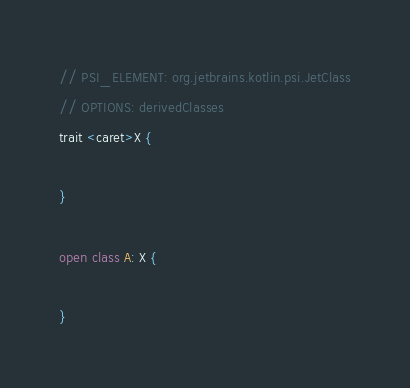Convert code to text. <code><loc_0><loc_0><loc_500><loc_500><_Kotlin_>// PSI_ELEMENT: org.jetbrains.kotlin.psi.JetClass
// OPTIONS: derivedClasses
trait <caret>X {

}

open class A: X {

}
</code> 